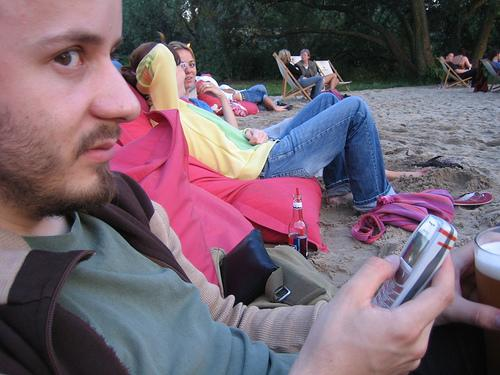What kind of ground are these people sitting on? sand 